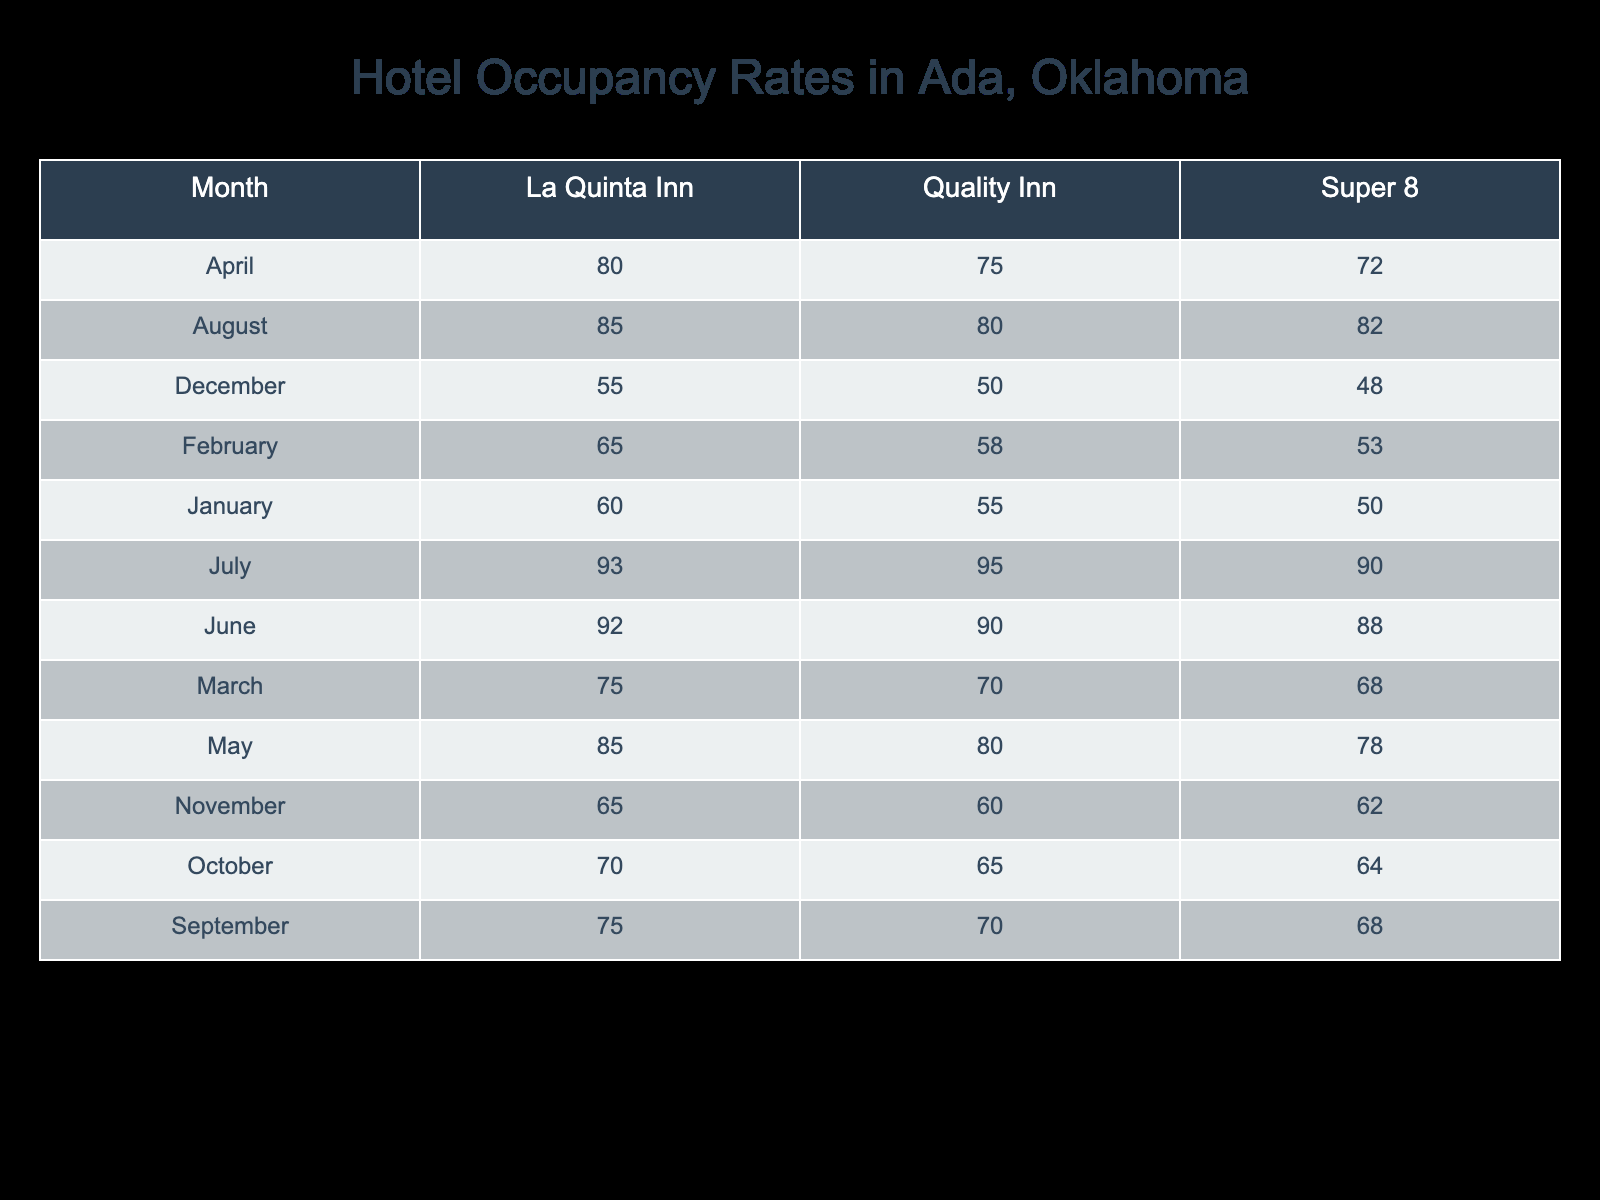What is the highest occupancy rate for Quality Inn? Looking through the data for Quality Inn, the highest occupancy rate is found in July at 95.
Answer: 95 Which hotel had the lowest occupancy rate in December? In December, we observe the occupancy rates for each hotel: Quality Inn at 50, La Quinta Inn at 55, and Super 8 at 48. The lowest rate is 48 for Super 8.
Answer: 48 What is the average occupancy rate for La Quinta Inn across all months? First, we sum the occupancy rates for La Quinta Inn: 60 + 65 + 75 + 80 + 85 + 92 + 93 + 85 + 75 + 70 + 65 + 55 =  911. There are 12 months, so we divide 911 by 12, resulting in an average occupancy rate of approximately 75.92.
Answer: 75.92 Is the occupancy rate for Super 8 in May higher than in June? In May, the occupancy rate for Super 8 is 78, and in June, it is 88. Since 78 is less than 88, the statement is false.
Answer: No What is the total occupancy rate for Quality Inn over the entire year? Summing the monthly occupancy rates for Quality Inn yields 55 + 58 + 70 + 75 + 80 + 90 + 95 + 80 + 70 + 65 + 60 + 50 =  1000.
Answer: 1000 Which month had the highest overall occupancy rate considering all hotels? To find this, we sum the occupancy rates for each hotel by month. The totals per month are: January (165), February (176), March (213), April (227), May (243), June (270), July (278), August (247), September (213), October (199), November (187), December (153). July has the highest total with 278.
Answer: July Is it true that the occupancy rate at La Quinta Inn remained consistent throughout the year? Reviewing the occupancy rates for La Quinta Inn shows variations: 60, 65, 75, 80, 85, 92, 93, 85, 75, 70, 65, 55. As there are fluctuations, the statement is false.
Answer: No What is the difference in occupancy rates for Quality Inn between the months of April and October? In April, the occupancy rate for Quality Inn is 75, while in October, it is 65. The difference is 75 - 65 = 10.
Answer: 10 